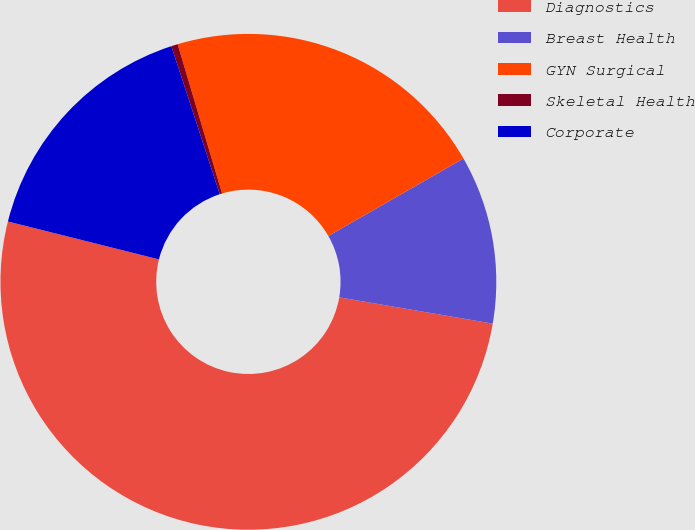Convert chart. <chart><loc_0><loc_0><loc_500><loc_500><pie_chart><fcel>Diagnostics<fcel>Breast Health<fcel>GYN Surgical<fcel>Skeletal Health<fcel>Corporate<nl><fcel>51.21%<fcel>10.98%<fcel>21.32%<fcel>0.42%<fcel>16.06%<nl></chart> 